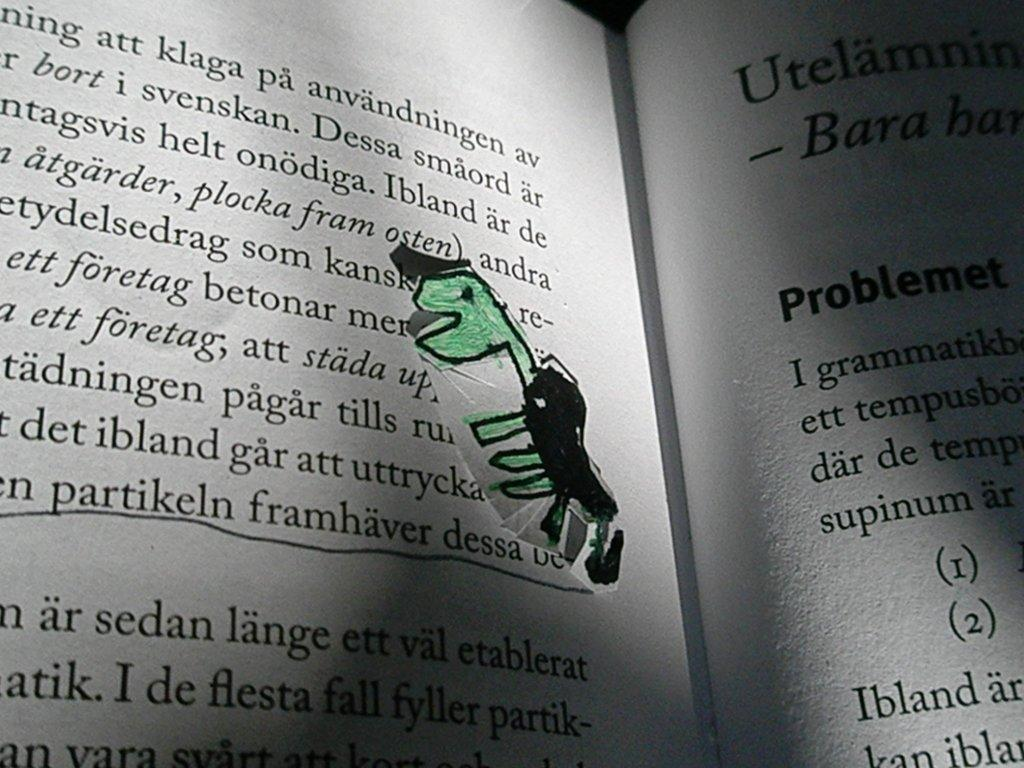<image>
Share a concise interpretation of the image provided. A poorly drawn dinosaur on a page of the book eating the word betonar. 